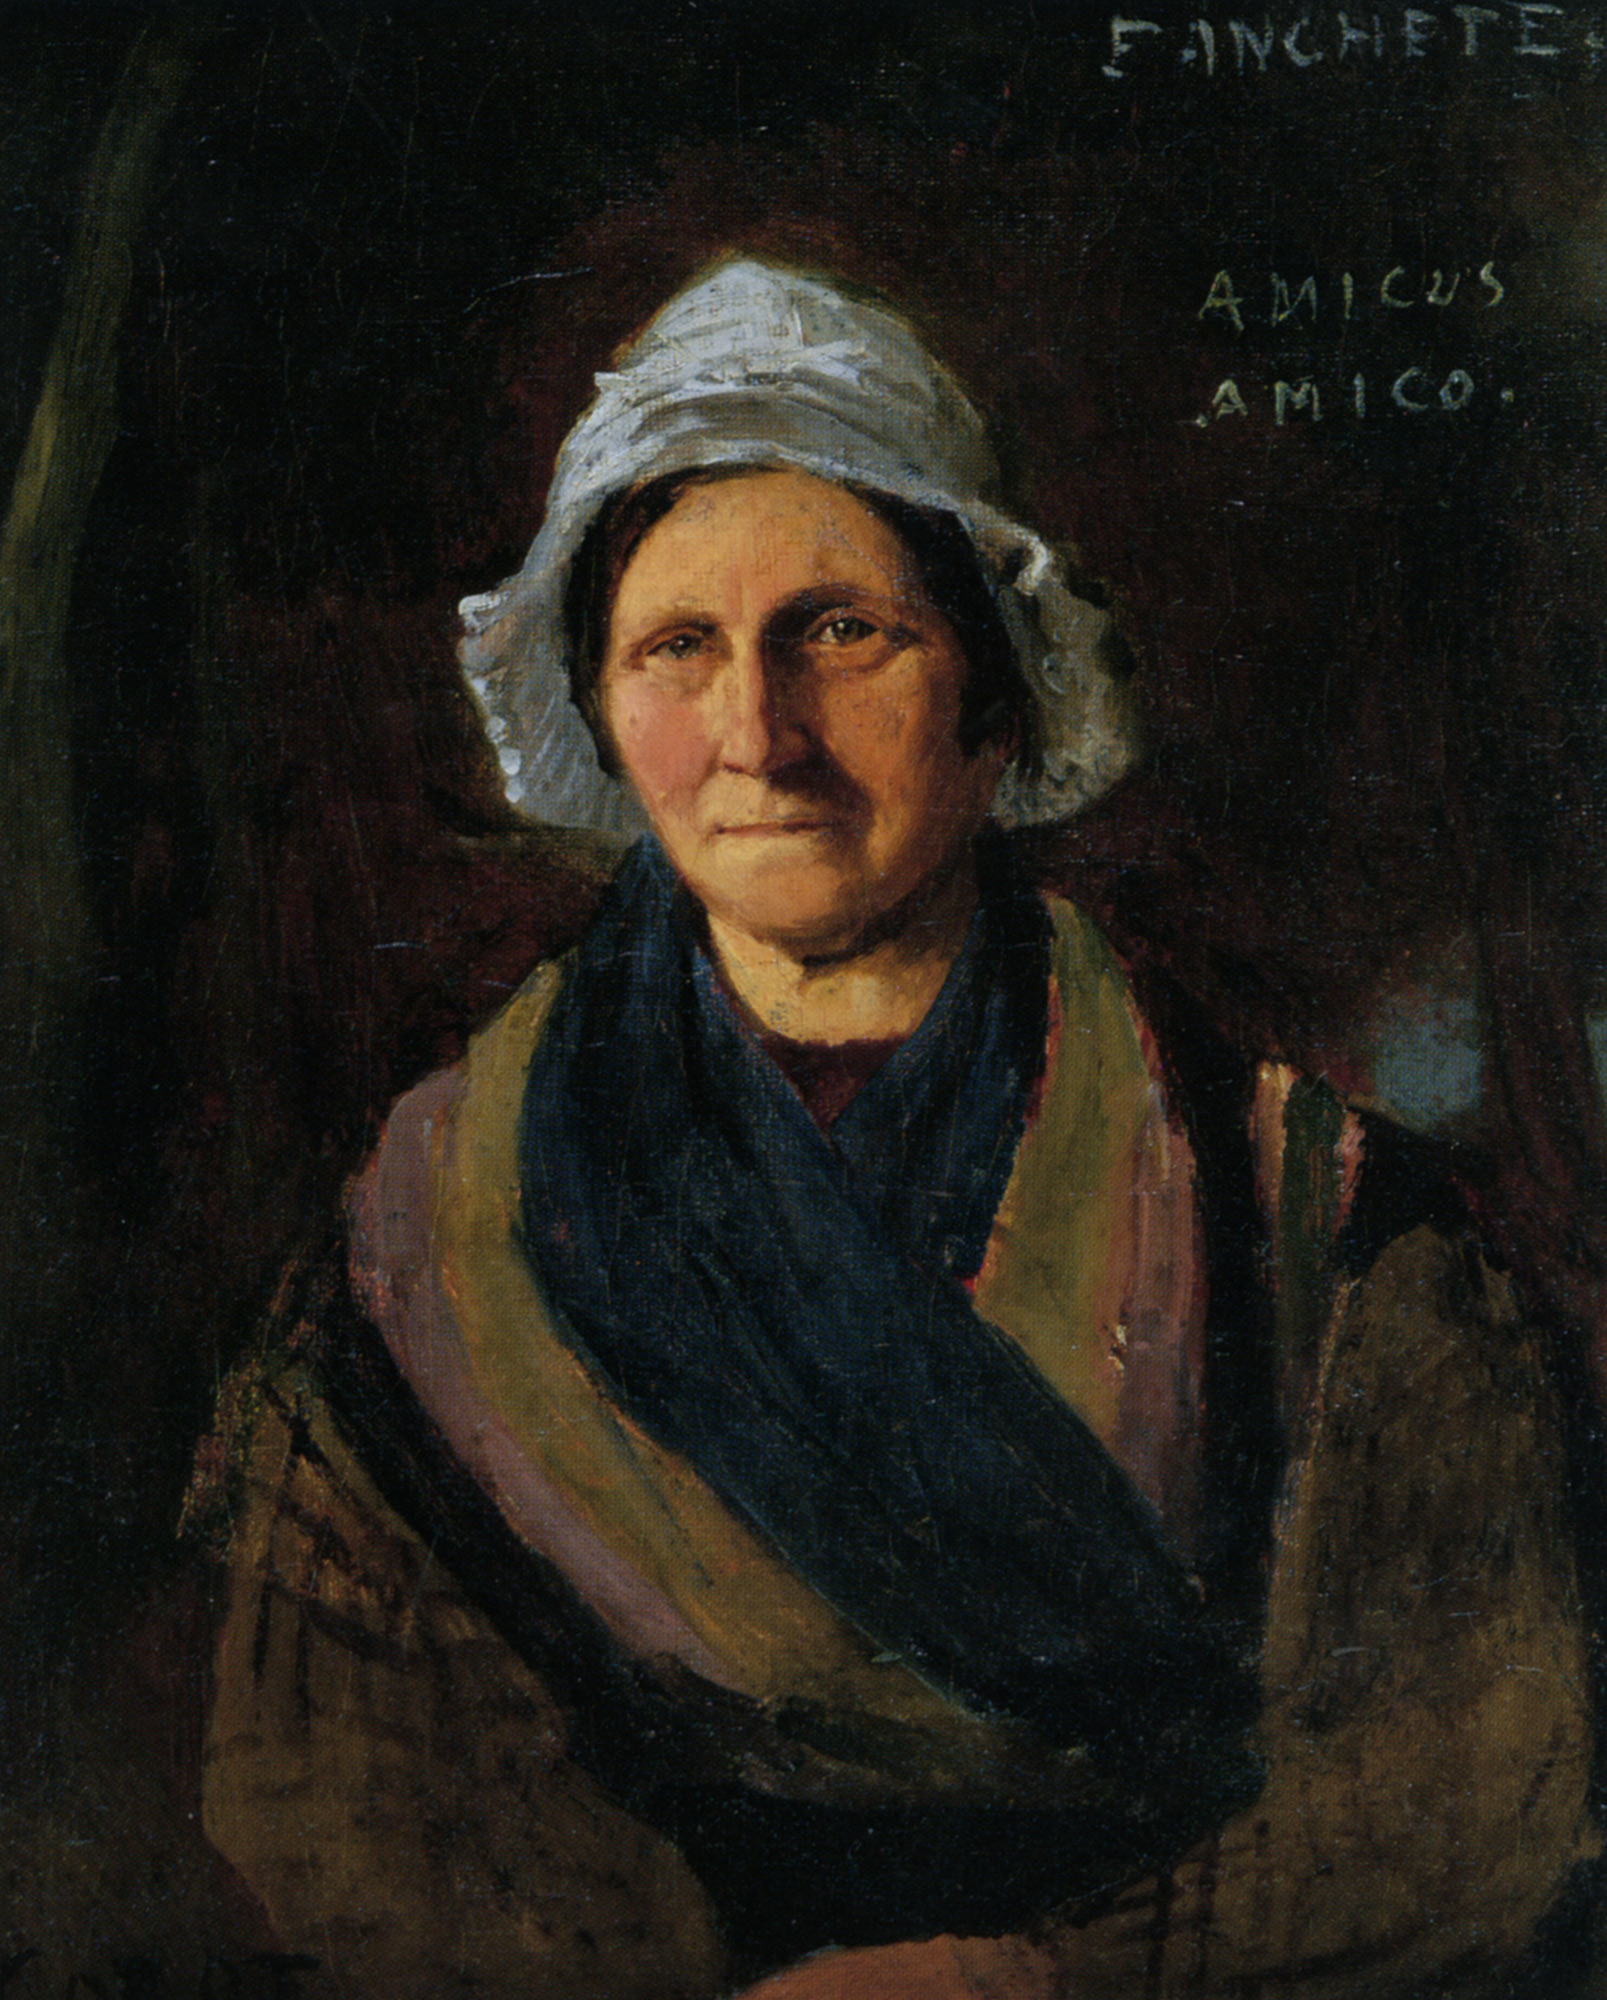What story do you think the painting tells about the woman? The painting seems to tell a story of a woman from an earlier time, perhaps in the 18th or 19th century, given her attire. Her expression is solemn and thoughtful, hinting at a life filled with experiences and perhaps hardships. The careful detail in her face suggests a woman of strong character and resilience. The dark background could symbolize the trials she has faced, while the light bonnet and shawl suggest hope, purity, or wisdom. The inscription 'AMICUS AMICO' translates to 'friend to a friend,' which could imply that she was a beloved individual, a friend, or a confidant. 